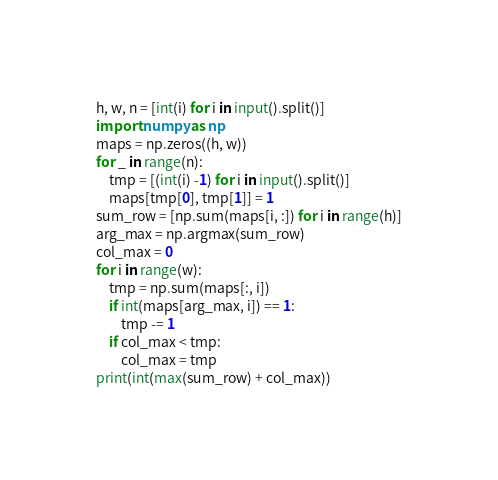Convert code to text. <code><loc_0><loc_0><loc_500><loc_500><_Python_>h, w, n = [int(i) for i in input().split()]
import numpy as np
maps = np.zeros((h, w))
for _ in range(n):
    tmp = [(int(i) -1) for i in input().split()]
    maps[tmp[0], tmp[1]] = 1
sum_row = [np.sum(maps[i, :]) for i in range(h)]
arg_max = np.argmax(sum_row)
col_max = 0
for i in range(w):
    tmp = np.sum(maps[:, i])
    if int(maps[arg_max, i]) == 1:
        tmp -= 1
    if col_max < tmp:
        col_max = tmp
print(int(max(sum_row) + col_max))
</code> 